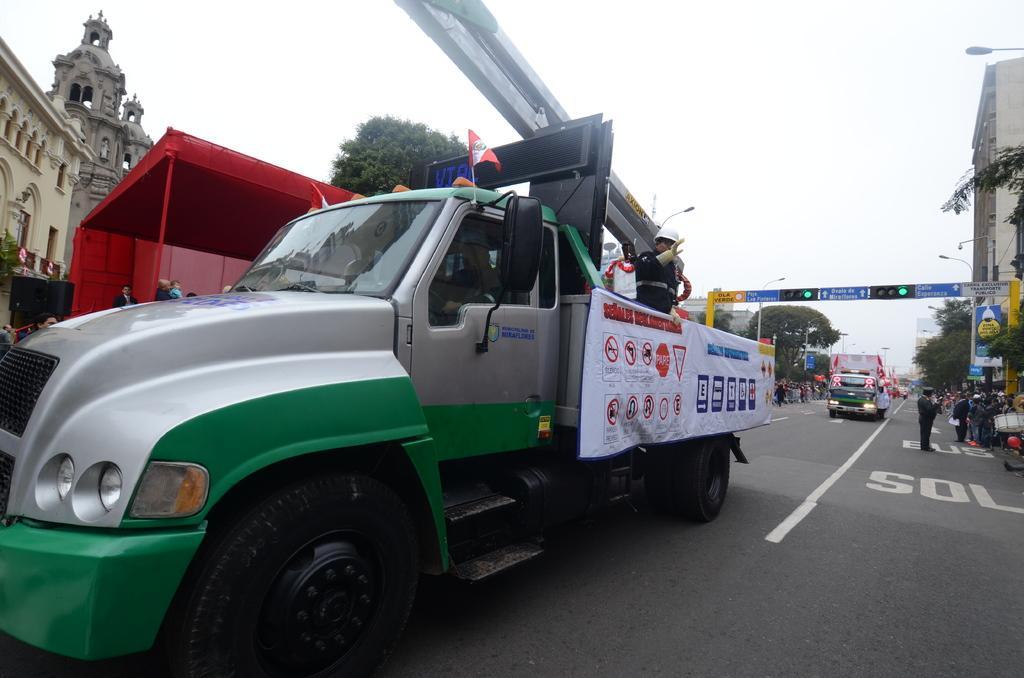Can you describe this image briefly? In this image I can see a vehicle which is grey and green in color, a flag on the vehicle, few persons in the vehicle and a white colored banner to the vehicle. I can see a red colored tent, few persons, few vehicles on the road, few traffic signals, few trees and few buildings. In the background I can see the sky. 